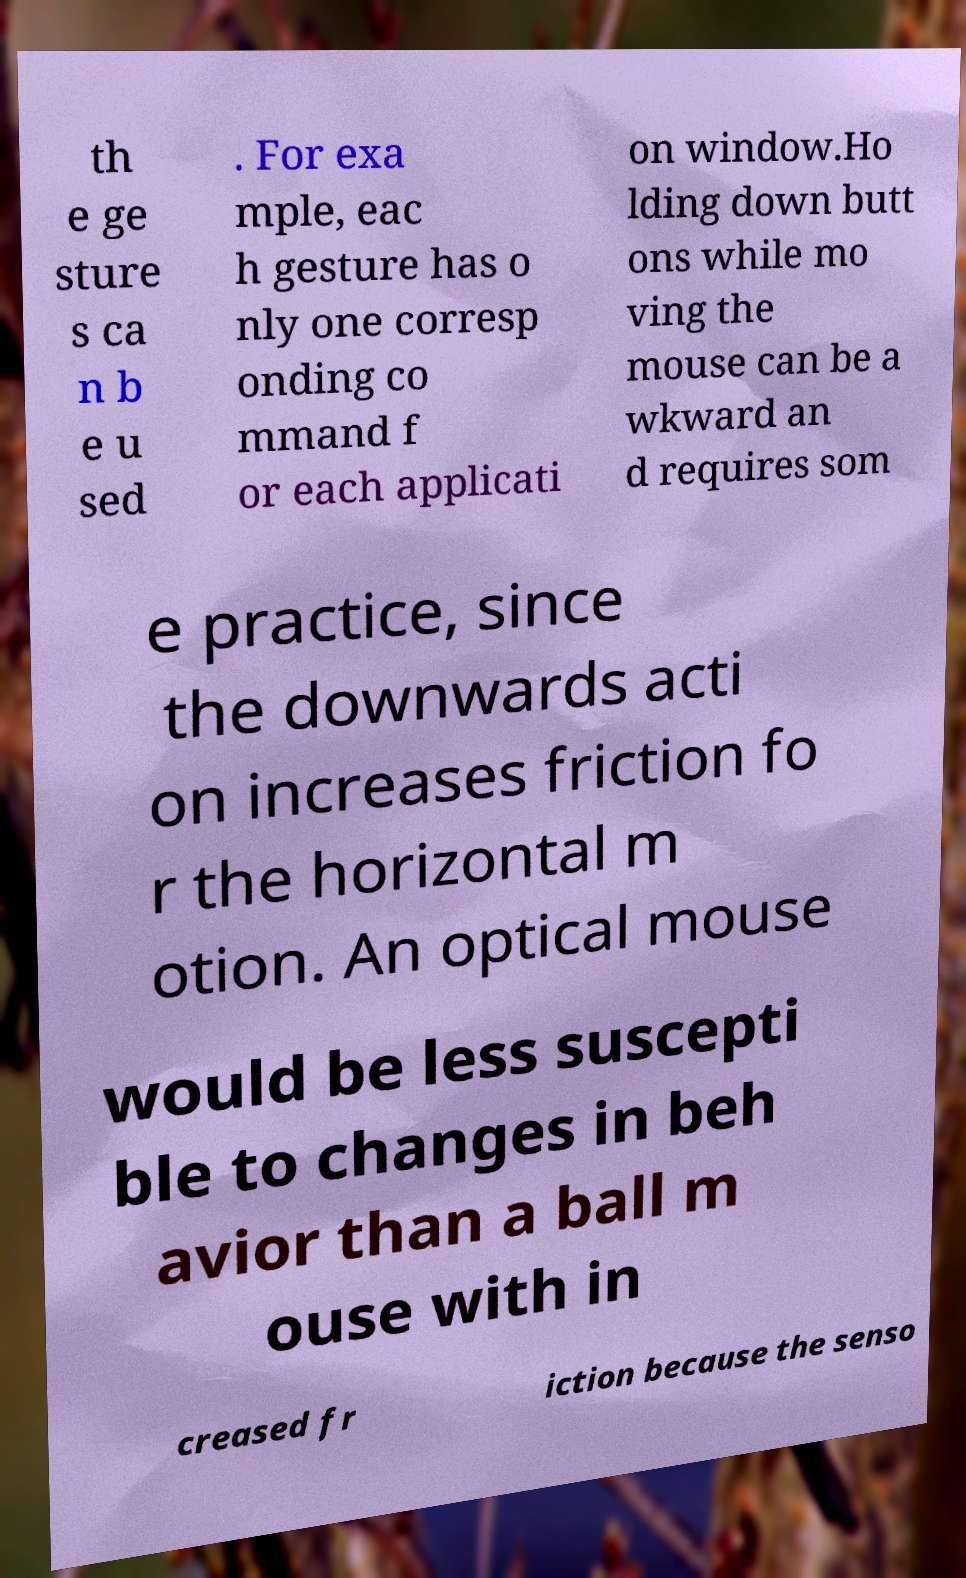Please read and relay the text visible in this image. What does it say? th e ge sture s ca n b e u sed . For exa mple, eac h gesture has o nly one corresp onding co mmand f or each applicati on window.Ho lding down butt ons while mo ving the mouse can be a wkward an d requires som e practice, since the downwards acti on increases friction fo r the horizontal m otion. An optical mouse would be less suscepti ble to changes in beh avior than a ball m ouse with in creased fr iction because the senso 